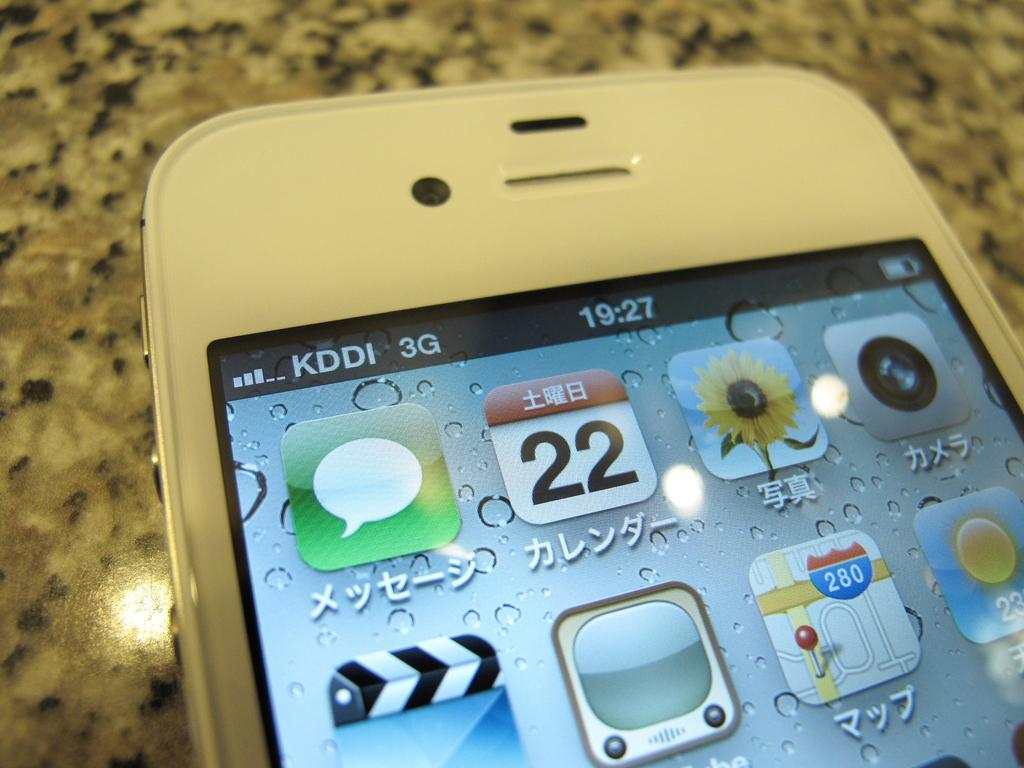<image>
Relay a brief, clear account of the picture shown. Phone screen that has the current time at 19:27. 